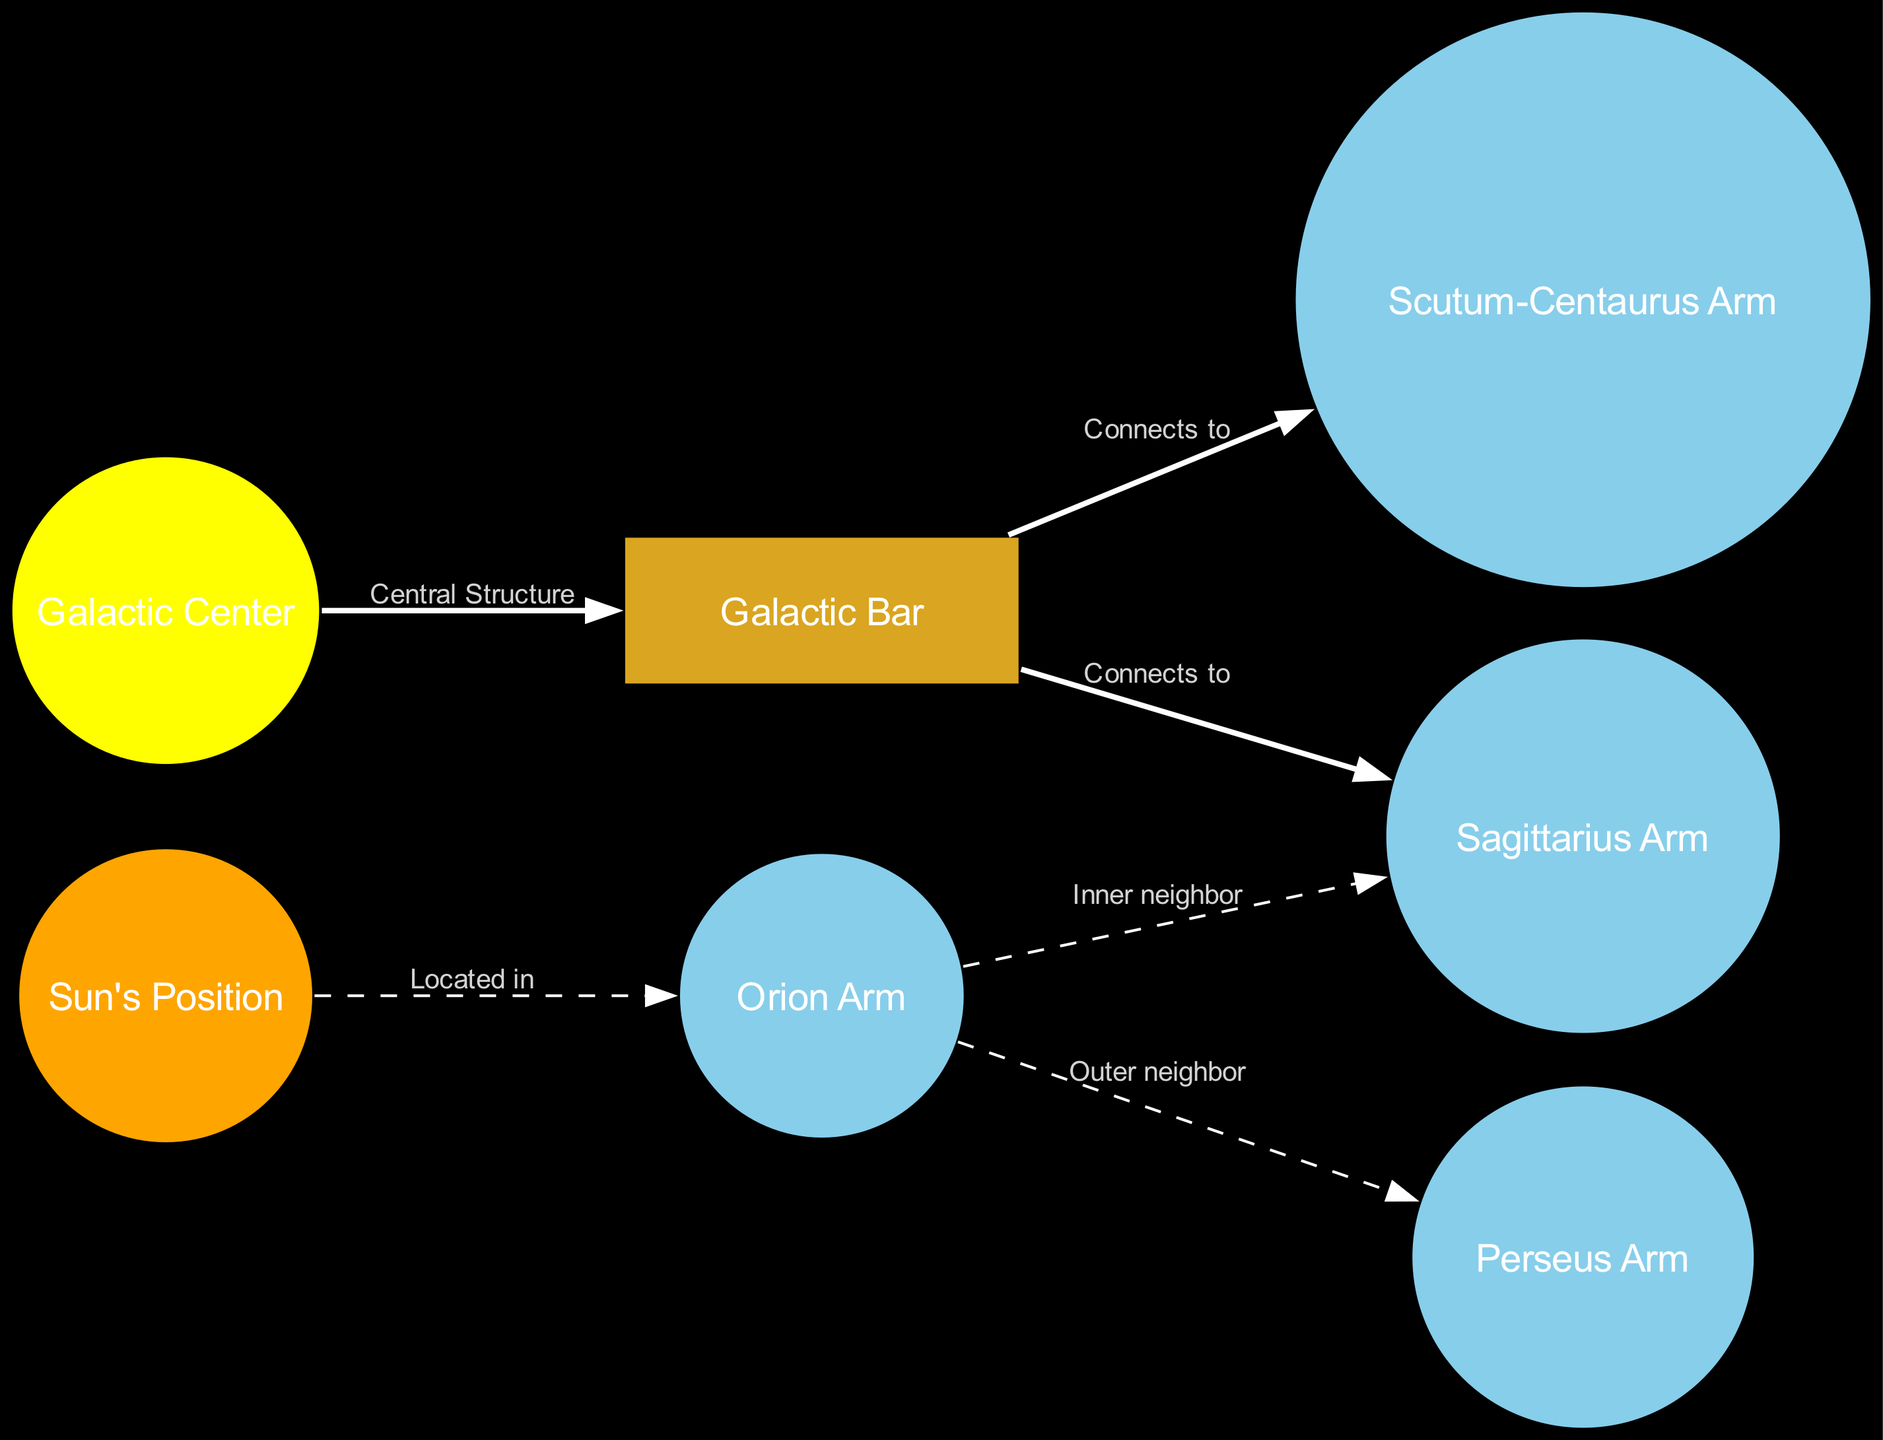What is the central structure of the Milky Way galaxy? The diagram indicates that the central structure is labeled as the "Galactic Bar," which is connected to the Galactic Center.
Answer: Galactic Bar Where is the Sun located in relation to the Orion Arm? The diagram shows that the Sun is located within the "Orion Arm," indicating its position within one of the galaxy's spiral arms.
Answer: Orion Arm How many arms are directly connected to the Galactic Bar? By analyzing the edges from the Galactic Bar, we see two arms (Sagittarius and Scutum) connected to it, leading to a total of two connections.
Answer: 2 What is the outer neighbor of the Orion Arm? The diagram states that the Orion Arm's outer neighbor is the "Perseus Arm," showcasing its position relative to other arms in the galaxy.
Answer: Perseus Arm Which arm is located inner to the Orion Arm? The diagram specifies that the "Sagittarius Arm" is the inner neighbor to the Orion Arm, indicating their relative positioning.
Answer: Sagittarius Arm What is the color representation of the Galactic Center in the diagram? The diagram uses yellow to represent the Galactic Center, differentiating it from other nodes in the galaxy’s structure.
Answer: Yellow Which arm does the Sun neighbor to the inner side? According to the information in the diagram, the Sun is positioned adjacent to the Sagittarius Arm on the inner side, demonstrating its placements among neighboring arms.
Answer: Sagittarius Arm What connects the Central Structure to the Sagittarius Arm? The relationship between the Central Structure (Galactic Bar) and the Sagittarius Arm is labeled as "Connects to," indicating a direct connection.
Answer: Connects to 